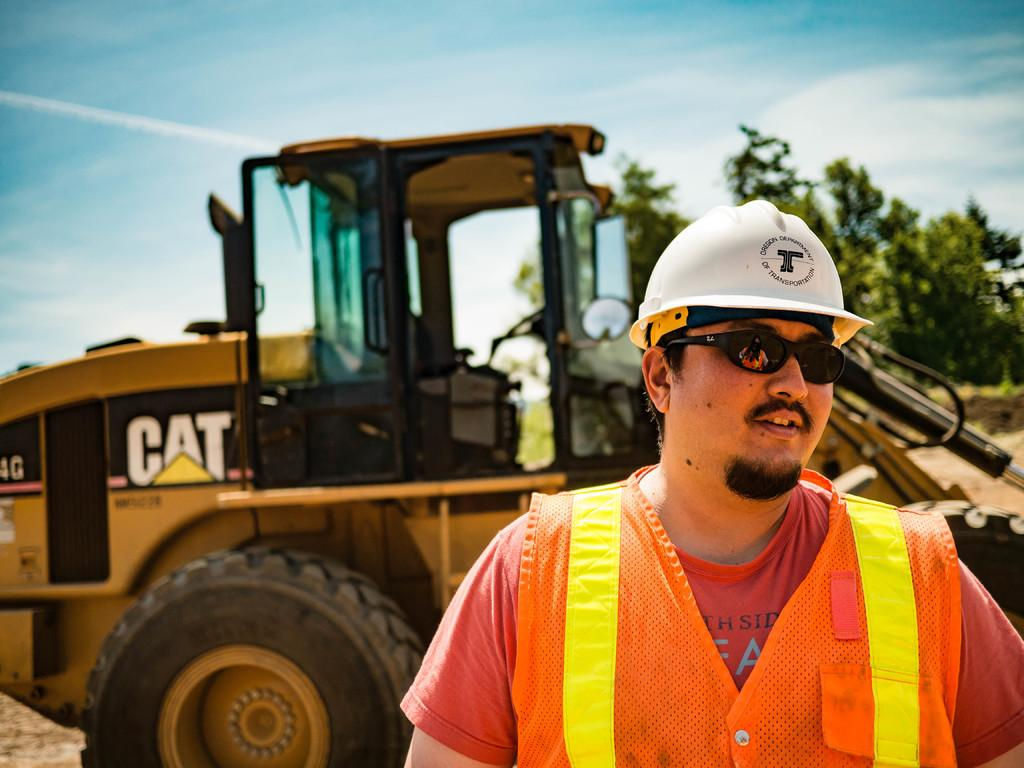What is the main subject of the image? There is a person in the image. What type of clothing is the person wearing? The person is wearing a jacket, goggles, and a helmet. What can be seen in the background of the image? There is a crane, trees, and the sky visible in the background of the image. What type of badge is the person wearing on their helmet in the image? There is no badge visible on the person's helmet in the image. How many bikes are parked next to the person in the image? There are no bikes present in the image. 